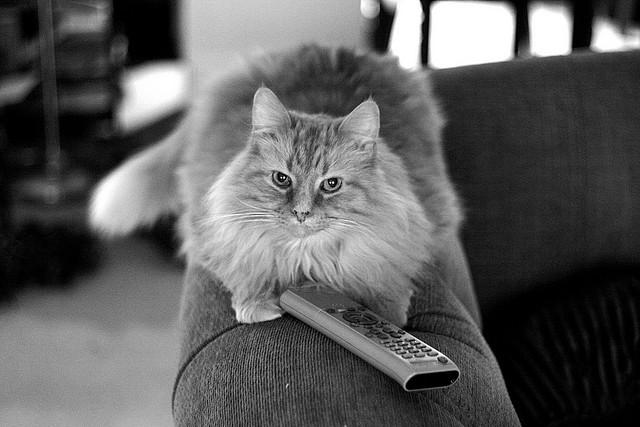How is the cat on the couch illuminated? light 